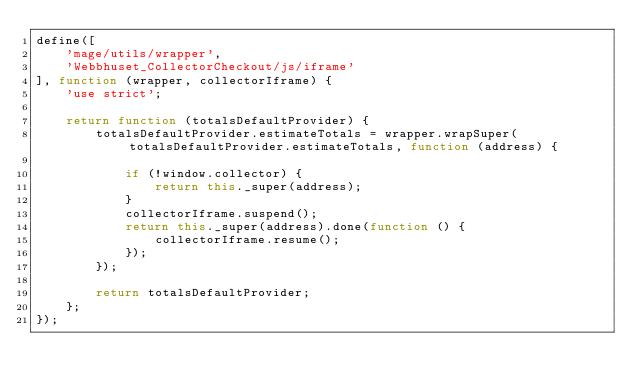Convert code to text. <code><loc_0><loc_0><loc_500><loc_500><_JavaScript_>define([
    'mage/utils/wrapper',
    'Webbhuset_CollectorCheckout/js/iframe'
], function (wrapper, collectorIframe) {
    'use strict';

    return function (totalsDefaultProvider) {
        totalsDefaultProvider.estimateTotals = wrapper.wrapSuper(totalsDefaultProvider.estimateTotals, function (address) {

            if (!window.collector) {
                return this._super(address);
            }
            collectorIframe.suspend();
            return this._super(address).done(function () {
                collectorIframe.resume();
            });
        });

        return totalsDefaultProvider;
    };
});
</code> 